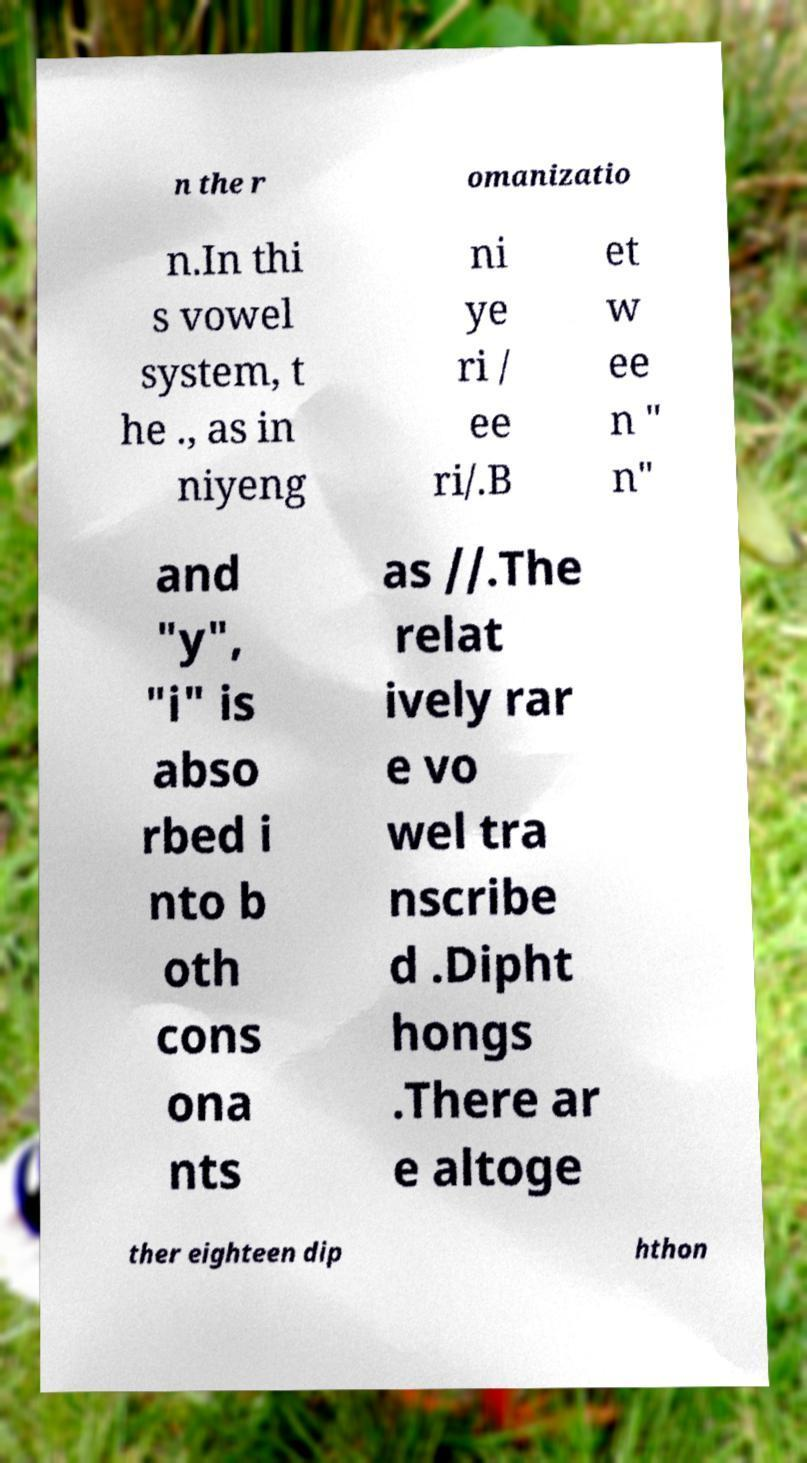Can you accurately transcribe the text from the provided image for me? n the r omanizatio n.In thi s vowel system, t he ., as in niyeng ni ye ri / ee ri/.B et w ee n " n" and "y", "i" is abso rbed i nto b oth cons ona nts as //.The relat ively rar e vo wel tra nscribe d .Dipht hongs .There ar e altoge ther eighteen dip hthon 